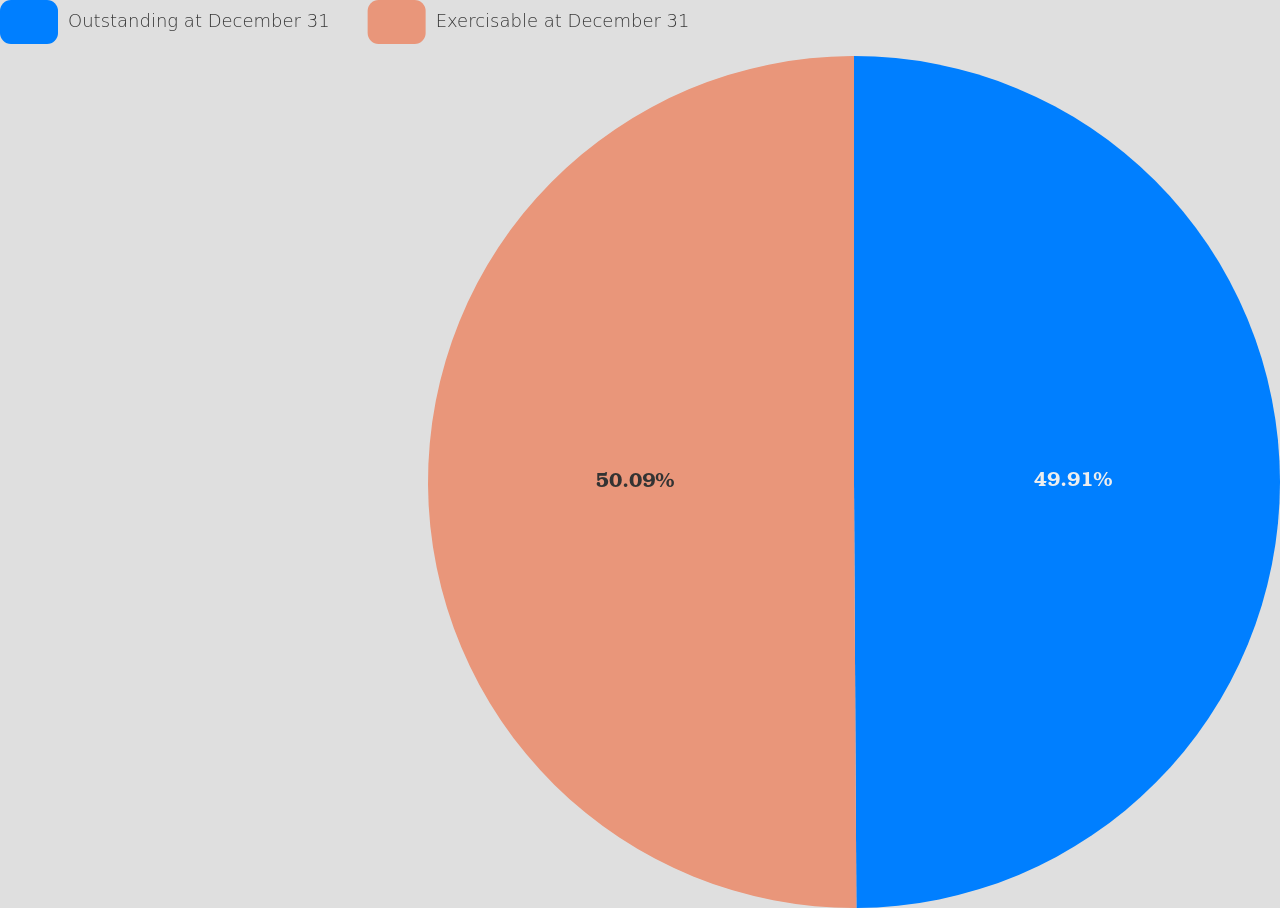Convert chart. <chart><loc_0><loc_0><loc_500><loc_500><pie_chart><fcel>Outstanding at December 31<fcel>Exercisable at December 31<nl><fcel>49.91%<fcel>50.09%<nl></chart> 